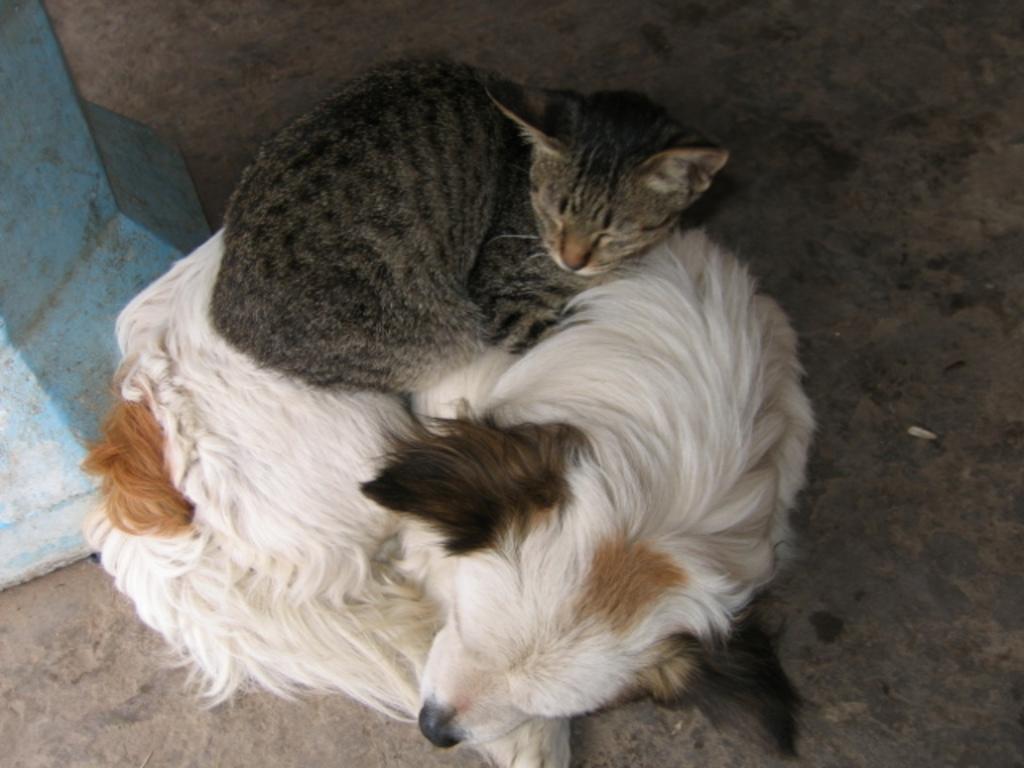How would you summarize this image in a sentence or two? In this picture we can see the dog laying on the surface and we can observe the cat laying on the dog. 